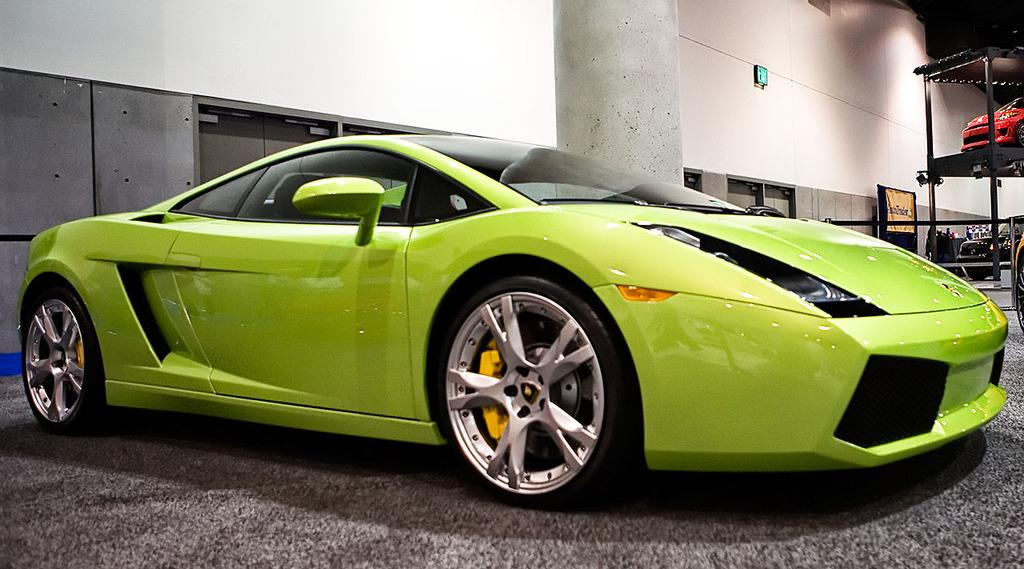What is the main subject of the image? The main subject of the image is a car. Can you describe the car's location in the image? The car is on a path in the image. What is the color of the car? The car is green in color. What can be seen in the background of the image? There is a pillar and a wall in the background of the image, as well as other cars. What type of game is being played on the car's roof in the image? There is no game being played on the car's roof in the image; the car's roof is not visible. What kind of polish is being used to clean the car's windows in the image? There is no indication of any polish or cleaning activity in the image. 